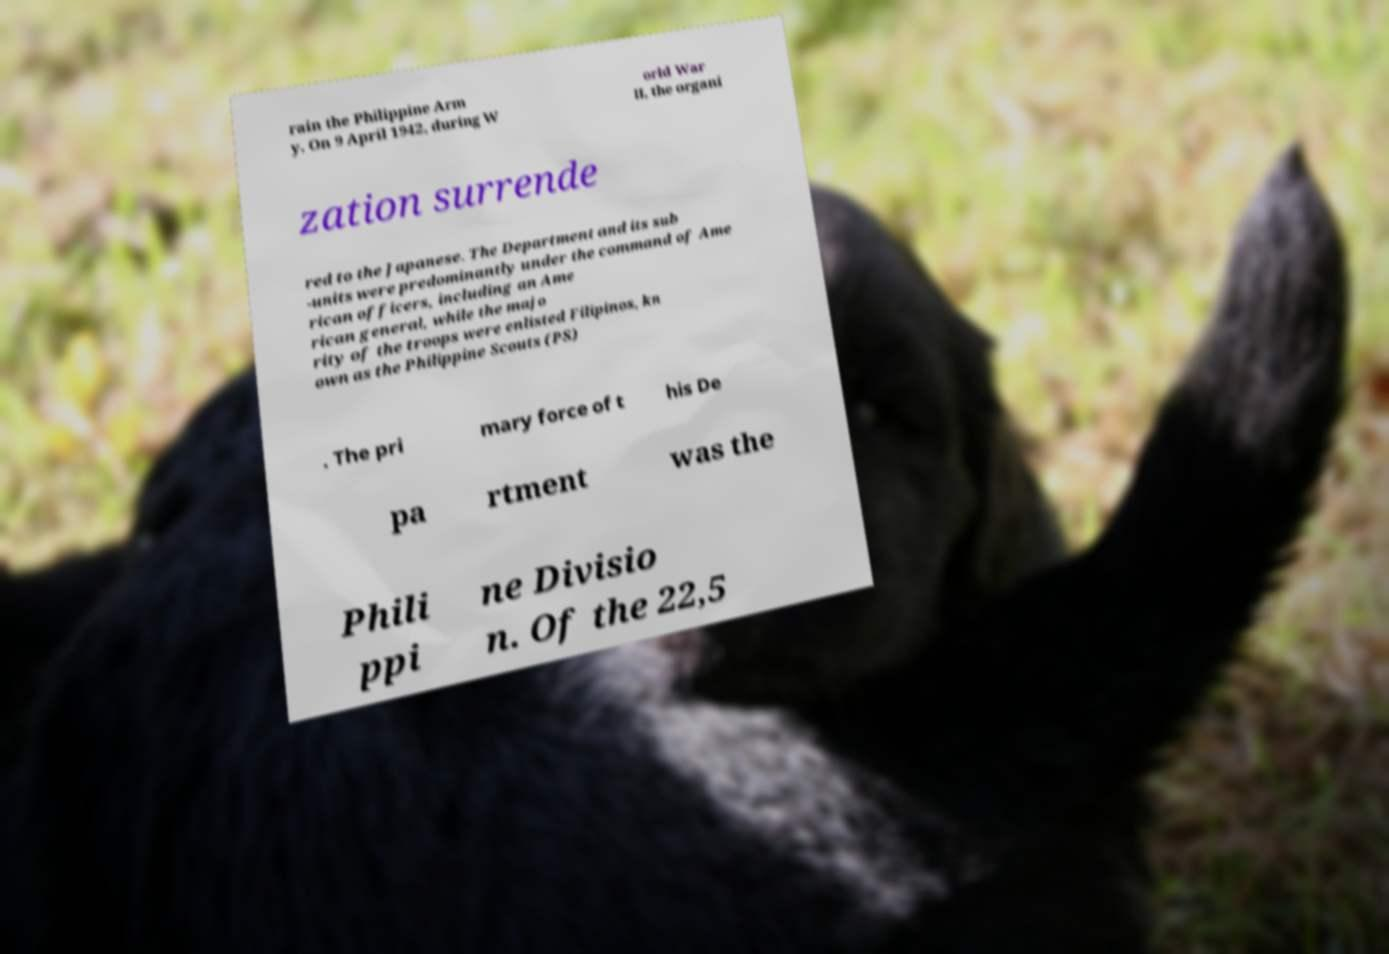Can you accurately transcribe the text from the provided image for me? rain the Philippine Arm y. On 9 April 1942, during W orld War II, the organi zation surrende red to the Japanese. The Department and its sub -units were predominantly under the command of Ame rican officers, including an Ame rican general, while the majo rity of the troops were enlisted Filipinos, kn own as the Philippine Scouts (PS) . The pri mary force of t his De pa rtment was the Phili ppi ne Divisio n. Of the 22,5 